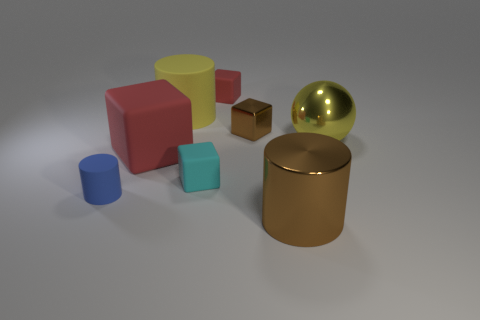Add 1 big things. How many objects exist? 9 Subtract all spheres. How many objects are left? 7 Subtract all tiny cyan rubber things. Subtract all yellow metallic cylinders. How many objects are left? 7 Add 8 yellow balls. How many yellow balls are left? 9 Add 3 small cyan cubes. How many small cyan cubes exist? 4 Subtract 1 brown cylinders. How many objects are left? 7 